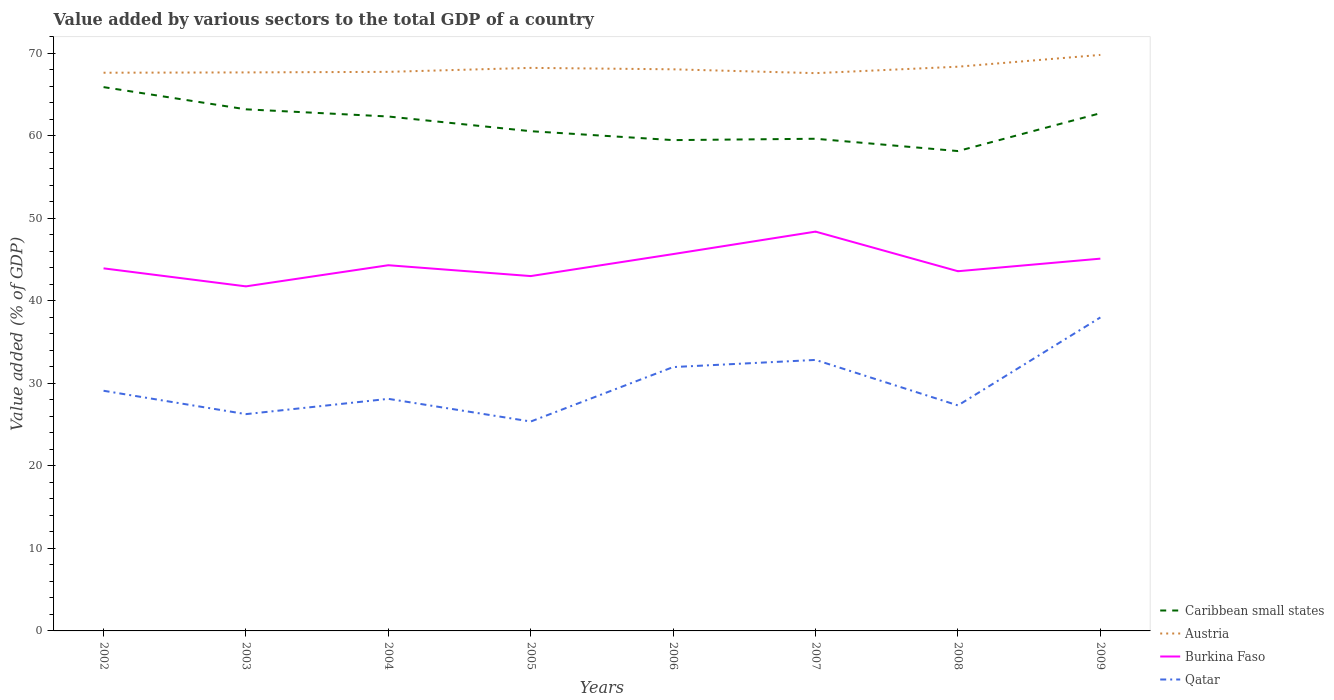How many different coloured lines are there?
Your answer should be compact. 4. Does the line corresponding to Burkina Faso intersect with the line corresponding to Caribbean small states?
Make the answer very short. No. Across all years, what is the maximum value added by various sectors to the total GDP in Caribbean small states?
Make the answer very short. 58.14. What is the total value added by various sectors to the total GDP in Austria in the graph?
Keep it short and to the point. -0.32. What is the difference between the highest and the second highest value added by various sectors to the total GDP in Burkina Faso?
Give a very brief answer. 6.63. What is the difference between the highest and the lowest value added by various sectors to the total GDP in Austria?
Make the answer very short. 3. Is the value added by various sectors to the total GDP in Austria strictly greater than the value added by various sectors to the total GDP in Caribbean small states over the years?
Ensure brevity in your answer.  No. How many lines are there?
Your answer should be very brief. 4. What is the difference between two consecutive major ticks on the Y-axis?
Ensure brevity in your answer.  10. Does the graph contain any zero values?
Make the answer very short. No. Does the graph contain grids?
Your answer should be compact. No. Where does the legend appear in the graph?
Keep it short and to the point. Bottom right. What is the title of the graph?
Keep it short and to the point. Value added by various sectors to the total GDP of a country. What is the label or title of the X-axis?
Offer a terse response. Years. What is the label or title of the Y-axis?
Your answer should be compact. Value added (% of GDP). What is the Value added (% of GDP) in Caribbean small states in 2002?
Give a very brief answer. 65.88. What is the Value added (% of GDP) of Austria in 2002?
Provide a succinct answer. 67.63. What is the Value added (% of GDP) of Burkina Faso in 2002?
Ensure brevity in your answer.  43.93. What is the Value added (% of GDP) of Qatar in 2002?
Make the answer very short. 29.1. What is the Value added (% of GDP) of Caribbean small states in 2003?
Make the answer very short. 63.19. What is the Value added (% of GDP) in Austria in 2003?
Provide a short and direct response. 67.66. What is the Value added (% of GDP) of Burkina Faso in 2003?
Your answer should be compact. 41.74. What is the Value added (% of GDP) of Qatar in 2003?
Make the answer very short. 26.26. What is the Value added (% of GDP) in Caribbean small states in 2004?
Give a very brief answer. 62.32. What is the Value added (% of GDP) of Austria in 2004?
Provide a succinct answer. 67.73. What is the Value added (% of GDP) of Burkina Faso in 2004?
Offer a very short reply. 44.3. What is the Value added (% of GDP) of Qatar in 2004?
Offer a very short reply. 28.12. What is the Value added (% of GDP) in Caribbean small states in 2005?
Keep it short and to the point. 60.54. What is the Value added (% of GDP) in Austria in 2005?
Make the answer very short. 68.21. What is the Value added (% of GDP) in Burkina Faso in 2005?
Give a very brief answer. 42.99. What is the Value added (% of GDP) of Qatar in 2005?
Your answer should be compact. 25.37. What is the Value added (% of GDP) in Caribbean small states in 2006?
Offer a very short reply. 59.46. What is the Value added (% of GDP) in Austria in 2006?
Offer a very short reply. 68.04. What is the Value added (% of GDP) in Burkina Faso in 2006?
Your response must be concise. 45.65. What is the Value added (% of GDP) in Qatar in 2006?
Make the answer very short. 31.97. What is the Value added (% of GDP) of Caribbean small states in 2007?
Offer a terse response. 59.63. What is the Value added (% of GDP) of Austria in 2007?
Your response must be concise. 67.57. What is the Value added (% of GDP) of Burkina Faso in 2007?
Your answer should be compact. 48.38. What is the Value added (% of GDP) of Qatar in 2007?
Provide a succinct answer. 32.83. What is the Value added (% of GDP) in Caribbean small states in 2008?
Keep it short and to the point. 58.14. What is the Value added (% of GDP) of Austria in 2008?
Make the answer very short. 68.36. What is the Value added (% of GDP) in Burkina Faso in 2008?
Provide a short and direct response. 43.58. What is the Value added (% of GDP) in Qatar in 2008?
Make the answer very short. 27.32. What is the Value added (% of GDP) in Caribbean small states in 2009?
Your answer should be very brief. 62.72. What is the Value added (% of GDP) of Austria in 2009?
Your response must be concise. 69.79. What is the Value added (% of GDP) in Burkina Faso in 2009?
Your answer should be compact. 45.1. What is the Value added (% of GDP) in Qatar in 2009?
Provide a short and direct response. 37.98. Across all years, what is the maximum Value added (% of GDP) in Caribbean small states?
Provide a succinct answer. 65.88. Across all years, what is the maximum Value added (% of GDP) in Austria?
Ensure brevity in your answer.  69.79. Across all years, what is the maximum Value added (% of GDP) of Burkina Faso?
Your response must be concise. 48.38. Across all years, what is the maximum Value added (% of GDP) of Qatar?
Provide a succinct answer. 37.98. Across all years, what is the minimum Value added (% of GDP) of Caribbean small states?
Offer a very short reply. 58.14. Across all years, what is the minimum Value added (% of GDP) in Austria?
Your answer should be very brief. 67.57. Across all years, what is the minimum Value added (% of GDP) of Burkina Faso?
Offer a terse response. 41.74. Across all years, what is the minimum Value added (% of GDP) in Qatar?
Your answer should be compact. 25.37. What is the total Value added (% of GDP) in Caribbean small states in the graph?
Offer a very short reply. 491.88. What is the total Value added (% of GDP) in Austria in the graph?
Your answer should be very brief. 544.99. What is the total Value added (% of GDP) in Burkina Faso in the graph?
Offer a terse response. 355.67. What is the total Value added (% of GDP) in Qatar in the graph?
Offer a very short reply. 238.94. What is the difference between the Value added (% of GDP) of Caribbean small states in 2002 and that in 2003?
Provide a short and direct response. 2.69. What is the difference between the Value added (% of GDP) of Austria in 2002 and that in 2003?
Offer a terse response. -0.04. What is the difference between the Value added (% of GDP) of Burkina Faso in 2002 and that in 2003?
Your response must be concise. 2.18. What is the difference between the Value added (% of GDP) of Qatar in 2002 and that in 2003?
Your answer should be compact. 2.83. What is the difference between the Value added (% of GDP) in Caribbean small states in 2002 and that in 2004?
Provide a short and direct response. 3.56. What is the difference between the Value added (% of GDP) in Austria in 2002 and that in 2004?
Offer a very short reply. -0.11. What is the difference between the Value added (% of GDP) in Burkina Faso in 2002 and that in 2004?
Keep it short and to the point. -0.38. What is the difference between the Value added (% of GDP) in Qatar in 2002 and that in 2004?
Make the answer very short. 0.98. What is the difference between the Value added (% of GDP) of Caribbean small states in 2002 and that in 2005?
Provide a short and direct response. 5.34. What is the difference between the Value added (% of GDP) in Austria in 2002 and that in 2005?
Provide a short and direct response. -0.59. What is the difference between the Value added (% of GDP) in Burkina Faso in 2002 and that in 2005?
Your answer should be compact. 0.94. What is the difference between the Value added (% of GDP) in Qatar in 2002 and that in 2005?
Your response must be concise. 3.73. What is the difference between the Value added (% of GDP) of Caribbean small states in 2002 and that in 2006?
Provide a succinct answer. 6.42. What is the difference between the Value added (% of GDP) in Austria in 2002 and that in 2006?
Your answer should be very brief. -0.41. What is the difference between the Value added (% of GDP) of Burkina Faso in 2002 and that in 2006?
Your answer should be compact. -1.73. What is the difference between the Value added (% of GDP) in Qatar in 2002 and that in 2006?
Your answer should be very brief. -2.87. What is the difference between the Value added (% of GDP) in Caribbean small states in 2002 and that in 2007?
Offer a very short reply. 6.25. What is the difference between the Value added (% of GDP) in Austria in 2002 and that in 2007?
Provide a short and direct response. 0.05. What is the difference between the Value added (% of GDP) of Burkina Faso in 2002 and that in 2007?
Give a very brief answer. -4.45. What is the difference between the Value added (% of GDP) of Qatar in 2002 and that in 2007?
Your answer should be compact. -3.74. What is the difference between the Value added (% of GDP) of Caribbean small states in 2002 and that in 2008?
Your answer should be compact. 7.75. What is the difference between the Value added (% of GDP) of Austria in 2002 and that in 2008?
Your response must be concise. -0.73. What is the difference between the Value added (% of GDP) of Burkina Faso in 2002 and that in 2008?
Ensure brevity in your answer.  0.35. What is the difference between the Value added (% of GDP) of Qatar in 2002 and that in 2008?
Give a very brief answer. 1.78. What is the difference between the Value added (% of GDP) in Caribbean small states in 2002 and that in 2009?
Your answer should be compact. 3.16. What is the difference between the Value added (% of GDP) in Austria in 2002 and that in 2009?
Offer a very short reply. -2.16. What is the difference between the Value added (% of GDP) in Burkina Faso in 2002 and that in 2009?
Keep it short and to the point. -1.18. What is the difference between the Value added (% of GDP) in Qatar in 2002 and that in 2009?
Make the answer very short. -8.88. What is the difference between the Value added (% of GDP) of Caribbean small states in 2003 and that in 2004?
Provide a succinct answer. 0.87. What is the difference between the Value added (% of GDP) of Austria in 2003 and that in 2004?
Your answer should be very brief. -0.07. What is the difference between the Value added (% of GDP) of Burkina Faso in 2003 and that in 2004?
Provide a succinct answer. -2.56. What is the difference between the Value added (% of GDP) of Qatar in 2003 and that in 2004?
Provide a succinct answer. -1.85. What is the difference between the Value added (% of GDP) in Caribbean small states in 2003 and that in 2005?
Give a very brief answer. 2.65. What is the difference between the Value added (% of GDP) of Austria in 2003 and that in 2005?
Offer a terse response. -0.55. What is the difference between the Value added (% of GDP) in Burkina Faso in 2003 and that in 2005?
Offer a very short reply. -1.25. What is the difference between the Value added (% of GDP) of Qatar in 2003 and that in 2005?
Your response must be concise. 0.89. What is the difference between the Value added (% of GDP) of Caribbean small states in 2003 and that in 2006?
Provide a short and direct response. 3.73. What is the difference between the Value added (% of GDP) in Austria in 2003 and that in 2006?
Your response must be concise. -0.38. What is the difference between the Value added (% of GDP) of Burkina Faso in 2003 and that in 2006?
Give a very brief answer. -3.91. What is the difference between the Value added (% of GDP) of Qatar in 2003 and that in 2006?
Your answer should be very brief. -5.7. What is the difference between the Value added (% of GDP) in Caribbean small states in 2003 and that in 2007?
Offer a terse response. 3.56. What is the difference between the Value added (% of GDP) of Austria in 2003 and that in 2007?
Provide a succinct answer. 0.09. What is the difference between the Value added (% of GDP) in Burkina Faso in 2003 and that in 2007?
Offer a very short reply. -6.63. What is the difference between the Value added (% of GDP) in Qatar in 2003 and that in 2007?
Your answer should be very brief. -6.57. What is the difference between the Value added (% of GDP) of Caribbean small states in 2003 and that in 2008?
Your answer should be compact. 5.06. What is the difference between the Value added (% of GDP) of Austria in 2003 and that in 2008?
Provide a succinct answer. -0.69. What is the difference between the Value added (% of GDP) in Burkina Faso in 2003 and that in 2008?
Offer a very short reply. -1.83. What is the difference between the Value added (% of GDP) in Qatar in 2003 and that in 2008?
Your answer should be compact. -1.06. What is the difference between the Value added (% of GDP) of Caribbean small states in 2003 and that in 2009?
Offer a very short reply. 0.47. What is the difference between the Value added (% of GDP) of Austria in 2003 and that in 2009?
Provide a short and direct response. -2.12. What is the difference between the Value added (% of GDP) of Burkina Faso in 2003 and that in 2009?
Provide a short and direct response. -3.36. What is the difference between the Value added (% of GDP) of Qatar in 2003 and that in 2009?
Offer a very short reply. -11.71. What is the difference between the Value added (% of GDP) in Caribbean small states in 2004 and that in 2005?
Ensure brevity in your answer.  1.78. What is the difference between the Value added (% of GDP) in Austria in 2004 and that in 2005?
Make the answer very short. -0.48. What is the difference between the Value added (% of GDP) in Burkina Faso in 2004 and that in 2005?
Give a very brief answer. 1.31. What is the difference between the Value added (% of GDP) in Qatar in 2004 and that in 2005?
Your response must be concise. 2.75. What is the difference between the Value added (% of GDP) of Caribbean small states in 2004 and that in 2006?
Ensure brevity in your answer.  2.86. What is the difference between the Value added (% of GDP) in Austria in 2004 and that in 2006?
Your response must be concise. -0.31. What is the difference between the Value added (% of GDP) in Burkina Faso in 2004 and that in 2006?
Provide a short and direct response. -1.35. What is the difference between the Value added (% of GDP) in Qatar in 2004 and that in 2006?
Offer a very short reply. -3.85. What is the difference between the Value added (% of GDP) in Caribbean small states in 2004 and that in 2007?
Your answer should be very brief. 2.69. What is the difference between the Value added (% of GDP) in Austria in 2004 and that in 2007?
Provide a succinct answer. 0.16. What is the difference between the Value added (% of GDP) of Burkina Faso in 2004 and that in 2007?
Keep it short and to the point. -4.07. What is the difference between the Value added (% of GDP) in Qatar in 2004 and that in 2007?
Offer a terse response. -4.72. What is the difference between the Value added (% of GDP) of Caribbean small states in 2004 and that in 2008?
Your response must be concise. 4.19. What is the difference between the Value added (% of GDP) of Austria in 2004 and that in 2008?
Your answer should be compact. -0.62. What is the difference between the Value added (% of GDP) of Burkina Faso in 2004 and that in 2008?
Your answer should be very brief. 0.73. What is the difference between the Value added (% of GDP) of Qatar in 2004 and that in 2008?
Offer a terse response. 0.8. What is the difference between the Value added (% of GDP) of Caribbean small states in 2004 and that in 2009?
Provide a short and direct response. -0.4. What is the difference between the Value added (% of GDP) of Austria in 2004 and that in 2009?
Your response must be concise. -2.05. What is the difference between the Value added (% of GDP) in Burkina Faso in 2004 and that in 2009?
Provide a succinct answer. -0.8. What is the difference between the Value added (% of GDP) in Qatar in 2004 and that in 2009?
Offer a terse response. -9.86. What is the difference between the Value added (% of GDP) of Caribbean small states in 2005 and that in 2006?
Your answer should be compact. 1.08. What is the difference between the Value added (% of GDP) in Austria in 2005 and that in 2006?
Offer a very short reply. 0.17. What is the difference between the Value added (% of GDP) in Burkina Faso in 2005 and that in 2006?
Your answer should be compact. -2.66. What is the difference between the Value added (% of GDP) of Qatar in 2005 and that in 2006?
Your answer should be compact. -6.6. What is the difference between the Value added (% of GDP) in Caribbean small states in 2005 and that in 2007?
Make the answer very short. 0.91. What is the difference between the Value added (% of GDP) of Austria in 2005 and that in 2007?
Your response must be concise. 0.64. What is the difference between the Value added (% of GDP) of Burkina Faso in 2005 and that in 2007?
Your answer should be compact. -5.39. What is the difference between the Value added (% of GDP) of Qatar in 2005 and that in 2007?
Give a very brief answer. -7.46. What is the difference between the Value added (% of GDP) in Caribbean small states in 2005 and that in 2008?
Keep it short and to the point. 2.41. What is the difference between the Value added (% of GDP) of Austria in 2005 and that in 2008?
Keep it short and to the point. -0.14. What is the difference between the Value added (% of GDP) in Burkina Faso in 2005 and that in 2008?
Offer a very short reply. -0.59. What is the difference between the Value added (% of GDP) in Qatar in 2005 and that in 2008?
Your response must be concise. -1.95. What is the difference between the Value added (% of GDP) in Caribbean small states in 2005 and that in 2009?
Ensure brevity in your answer.  -2.18. What is the difference between the Value added (% of GDP) of Austria in 2005 and that in 2009?
Keep it short and to the point. -1.57. What is the difference between the Value added (% of GDP) in Burkina Faso in 2005 and that in 2009?
Give a very brief answer. -2.11. What is the difference between the Value added (% of GDP) of Qatar in 2005 and that in 2009?
Make the answer very short. -12.61. What is the difference between the Value added (% of GDP) in Caribbean small states in 2006 and that in 2007?
Make the answer very short. -0.16. What is the difference between the Value added (% of GDP) of Austria in 2006 and that in 2007?
Ensure brevity in your answer.  0.47. What is the difference between the Value added (% of GDP) of Burkina Faso in 2006 and that in 2007?
Offer a very short reply. -2.72. What is the difference between the Value added (% of GDP) of Qatar in 2006 and that in 2007?
Give a very brief answer. -0.87. What is the difference between the Value added (% of GDP) in Caribbean small states in 2006 and that in 2008?
Your response must be concise. 1.33. What is the difference between the Value added (% of GDP) of Austria in 2006 and that in 2008?
Offer a terse response. -0.32. What is the difference between the Value added (% of GDP) of Burkina Faso in 2006 and that in 2008?
Ensure brevity in your answer.  2.08. What is the difference between the Value added (% of GDP) in Qatar in 2006 and that in 2008?
Offer a terse response. 4.65. What is the difference between the Value added (% of GDP) of Caribbean small states in 2006 and that in 2009?
Provide a short and direct response. -3.26. What is the difference between the Value added (% of GDP) of Austria in 2006 and that in 2009?
Provide a short and direct response. -1.75. What is the difference between the Value added (% of GDP) of Burkina Faso in 2006 and that in 2009?
Offer a very short reply. 0.55. What is the difference between the Value added (% of GDP) of Qatar in 2006 and that in 2009?
Keep it short and to the point. -6.01. What is the difference between the Value added (% of GDP) of Caribbean small states in 2007 and that in 2008?
Your answer should be compact. 1.49. What is the difference between the Value added (% of GDP) in Austria in 2007 and that in 2008?
Your answer should be compact. -0.78. What is the difference between the Value added (% of GDP) in Burkina Faso in 2007 and that in 2008?
Offer a very short reply. 4.8. What is the difference between the Value added (% of GDP) in Qatar in 2007 and that in 2008?
Offer a terse response. 5.51. What is the difference between the Value added (% of GDP) in Caribbean small states in 2007 and that in 2009?
Keep it short and to the point. -3.09. What is the difference between the Value added (% of GDP) of Austria in 2007 and that in 2009?
Your response must be concise. -2.21. What is the difference between the Value added (% of GDP) in Burkina Faso in 2007 and that in 2009?
Your response must be concise. 3.27. What is the difference between the Value added (% of GDP) in Qatar in 2007 and that in 2009?
Make the answer very short. -5.14. What is the difference between the Value added (% of GDP) of Caribbean small states in 2008 and that in 2009?
Provide a short and direct response. -4.58. What is the difference between the Value added (% of GDP) of Austria in 2008 and that in 2009?
Keep it short and to the point. -1.43. What is the difference between the Value added (% of GDP) in Burkina Faso in 2008 and that in 2009?
Your answer should be compact. -1.52. What is the difference between the Value added (% of GDP) of Qatar in 2008 and that in 2009?
Make the answer very short. -10.66. What is the difference between the Value added (% of GDP) of Caribbean small states in 2002 and the Value added (% of GDP) of Austria in 2003?
Your answer should be compact. -1.78. What is the difference between the Value added (% of GDP) in Caribbean small states in 2002 and the Value added (% of GDP) in Burkina Faso in 2003?
Provide a short and direct response. 24.14. What is the difference between the Value added (% of GDP) in Caribbean small states in 2002 and the Value added (% of GDP) in Qatar in 2003?
Offer a terse response. 39.62. What is the difference between the Value added (% of GDP) in Austria in 2002 and the Value added (% of GDP) in Burkina Faso in 2003?
Provide a short and direct response. 25.88. What is the difference between the Value added (% of GDP) of Austria in 2002 and the Value added (% of GDP) of Qatar in 2003?
Give a very brief answer. 41.36. What is the difference between the Value added (% of GDP) in Burkina Faso in 2002 and the Value added (% of GDP) in Qatar in 2003?
Your response must be concise. 17.66. What is the difference between the Value added (% of GDP) of Caribbean small states in 2002 and the Value added (% of GDP) of Austria in 2004?
Your answer should be compact. -1.85. What is the difference between the Value added (% of GDP) in Caribbean small states in 2002 and the Value added (% of GDP) in Burkina Faso in 2004?
Give a very brief answer. 21.58. What is the difference between the Value added (% of GDP) of Caribbean small states in 2002 and the Value added (% of GDP) of Qatar in 2004?
Offer a terse response. 37.77. What is the difference between the Value added (% of GDP) of Austria in 2002 and the Value added (% of GDP) of Burkina Faso in 2004?
Offer a very short reply. 23.32. What is the difference between the Value added (% of GDP) of Austria in 2002 and the Value added (% of GDP) of Qatar in 2004?
Your answer should be very brief. 39.51. What is the difference between the Value added (% of GDP) in Burkina Faso in 2002 and the Value added (% of GDP) in Qatar in 2004?
Make the answer very short. 15.81. What is the difference between the Value added (% of GDP) of Caribbean small states in 2002 and the Value added (% of GDP) of Austria in 2005?
Offer a very short reply. -2.33. What is the difference between the Value added (% of GDP) of Caribbean small states in 2002 and the Value added (% of GDP) of Burkina Faso in 2005?
Your response must be concise. 22.89. What is the difference between the Value added (% of GDP) in Caribbean small states in 2002 and the Value added (% of GDP) in Qatar in 2005?
Offer a very short reply. 40.51. What is the difference between the Value added (% of GDP) in Austria in 2002 and the Value added (% of GDP) in Burkina Faso in 2005?
Your answer should be compact. 24.64. What is the difference between the Value added (% of GDP) in Austria in 2002 and the Value added (% of GDP) in Qatar in 2005?
Keep it short and to the point. 42.26. What is the difference between the Value added (% of GDP) of Burkina Faso in 2002 and the Value added (% of GDP) of Qatar in 2005?
Provide a short and direct response. 18.56. What is the difference between the Value added (% of GDP) in Caribbean small states in 2002 and the Value added (% of GDP) in Austria in 2006?
Your answer should be very brief. -2.16. What is the difference between the Value added (% of GDP) of Caribbean small states in 2002 and the Value added (% of GDP) of Burkina Faso in 2006?
Make the answer very short. 20.23. What is the difference between the Value added (% of GDP) of Caribbean small states in 2002 and the Value added (% of GDP) of Qatar in 2006?
Give a very brief answer. 33.92. What is the difference between the Value added (% of GDP) in Austria in 2002 and the Value added (% of GDP) in Burkina Faso in 2006?
Make the answer very short. 21.97. What is the difference between the Value added (% of GDP) in Austria in 2002 and the Value added (% of GDP) in Qatar in 2006?
Ensure brevity in your answer.  35.66. What is the difference between the Value added (% of GDP) of Burkina Faso in 2002 and the Value added (% of GDP) of Qatar in 2006?
Your answer should be compact. 11.96. What is the difference between the Value added (% of GDP) of Caribbean small states in 2002 and the Value added (% of GDP) of Austria in 2007?
Give a very brief answer. -1.69. What is the difference between the Value added (% of GDP) of Caribbean small states in 2002 and the Value added (% of GDP) of Burkina Faso in 2007?
Your response must be concise. 17.51. What is the difference between the Value added (% of GDP) in Caribbean small states in 2002 and the Value added (% of GDP) in Qatar in 2007?
Offer a terse response. 33.05. What is the difference between the Value added (% of GDP) in Austria in 2002 and the Value added (% of GDP) in Burkina Faso in 2007?
Provide a succinct answer. 19.25. What is the difference between the Value added (% of GDP) in Austria in 2002 and the Value added (% of GDP) in Qatar in 2007?
Your answer should be very brief. 34.79. What is the difference between the Value added (% of GDP) of Burkina Faso in 2002 and the Value added (% of GDP) of Qatar in 2007?
Make the answer very short. 11.09. What is the difference between the Value added (% of GDP) of Caribbean small states in 2002 and the Value added (% of GDP) of Austria in 2008?
Offer a very short reply. -2.47. What is the difference between the Value added (% of GDP) of Caribbean small states in 2002 and the Value added (% of GDP) of Burkina Faso in 2008?
Offer a terse response. 22.3. What is the difference between the Value added (% of GDP) of Caribbean small states in 2002 and the Value added (% of GDP) of Qatar in 2008?
Offer a very short reply. 38.56. What is the difference between the Value added (% of GDP) in Austria in 2002 and the Value added (% of GDP) in Burkina Faso in 2008?
Offer a very short reply. 24.05. What is the difference between the Value added (% of GDP) of Austria in 2002 and the Value added (% of GDP) of Qatar in 2008?
Provide a short and direct response. 40.31. What is the difference between the Value added (% of GDP) in Burkina Faso in 2002 and the Value added (% of GDP) in Qatar in 2008?
Keep it short and to the point. 16.6. What is the difference between the Value added (% of GDP) of Caribbean small states in 2002 and the Value added (% of GDP) of Austria in 2009?
Provide a succinct answer. -3.9. What is the difference between the Value added (% of GDP) of Caribbean small states in 2002 and the Value added (% of GDP) of Burkina Faso in 2009?
Give a very brief answer. 20.78. What is the difference between the Value added (% of GDP) of Caribbean small states in 2002 and the Value added (% of GDP) of Qatar in 2009?
Offer a very short reply. 27.9. What is the difference between the Value added (% of GDP) of Austria in 2002 and the Value added (% of GDP) of Burkina Faso in 2009?
Your answer should be very brief. 22.52. What is the difference between the Value added (% of GDP) of Austria in 2002 and the Value added (% of GDP) of Qatar in 2009?
Your answer should be compact. 29.65. What is the difference between the Value added (% of GDP) in Burkina Faso in 2002 and the Value added (% of GDP) in Qatar in 2009?
Provide a succinct answer. 5.95. What is the difference between the Value added (% of GDP) of Caribbean small states in 2003 and the Value added (% of GDP) of Austria in 2004?
Offer a terse response. -4.54. What is the difference between the Value added (% of GDP) of Caribbean small states in 2003 and the Value added (% of GDP) of Burkina Faso in 2004?
Make the answer very short. 18.89. What is the difference between the Value added (% of GDP) in Caribbean small states in 2003 and the Value added (% of GDP) in Qatar in 2004?
Your response must be concise. 35.08. What is the difference between the Value added (% of GDP) of Austria in 2003 and the Value added (% of GDP) of Burkina Faso in 2004?
Provide a succinct answer. 23.36. What is the difference between the Value added (% of GDP) in Austria in 2003 and the Value added (% of GDP) in Qatar in 2004?
Your answer should be compact. 39.55. What is the difference between the Value added (% of GDP) in Burkina Faso in 2003 and the Value added (% of GDP) in Qatar in 2004?
Your answer should be compact. 13.63. What is the difference between the Value added (% of GDP) in Caribbean small states in 2003 and the Value added (% of GDP) in Austria in 2005?
Provide a short and direct response. -5.02. What is the difference between the Value added (% of GDP) of Caribbean small states in 2003 and the Value added (% of GDP) of Burkina Faso in 2005?
Your answer should be very brief. 20.2. What is the difference between the Value added (% of GDP) in Caribbean small states in 2003 and the Value added (% of GDP) in Qatar in 2005?
Provide a succinct answer. 37.82. What is the difference between the Value added (% of GDP) in Austria in 2003 and the Value added (% of GDP) in Burkina Faso in 2005?
Make the answer very short. 24.67. What is the difference between the Value added (% of GDP) of Austria in 2003 and the Value added (% of GDP) of Qatar in 2005?
Offer a terse response. 42.29. What is the difference between the Value added (% of GDP) of Burkina Faso in 2003 and the Value added (% of GDP) of Qatar in 2005?
Your answer should be compact. 16.37. What is the difference between the Value added (% of GDP) of Caribbean small states in 2003 and the Value added (% of GDP) of Austria in 2006?
Provide a short and direct response. -4.85. What is the difference between the Value added (% of GDP) in Caribbean small states in 2003 and the Value added (% of GDP) in Burkina Faso in 2006?
Keep it short and to the point. 17.54. What is the difference between the Value added (% of GDP) of Caribbean small states in 2003 and the Value added (% of GDP) of Qatar in 2006?
Your response must be concise. 31.23. What is the difference between the Value added (% of GDP) of Austria in 2003 and the Value added (% of GDP) of Burkina Faso in 2006?
Offer a terse response. 22.01. What is the difference between the Value added (% of GDP) in Austria in 2003 and the Value added (% of GDP) in Qatar in 2006?
Make the answer very short. 35.7. What is the difference between the Value added (% of GDP) in Burkina Faso in 2003 and the Value added (% of GDP) in Qatar in 2006?
Keep it short and to the point. 9.78. What is the difference between the Value added (% of GDP) of Caribbean small states in 2003 and the Value added (% of GDP) of Austria in 2007?
Offer a terse response. -4.38. What is the difference between the Value added (% of GDP) in Caribbean small states in 2003 and the Value added (% of GDP) in Burkina Faso in 2007?
Make the answer very short. 14.82. What is the difference between the Value added (% of GDP) in Caribbean small states in 2003 and the Value added (% of GDP) in Qatar in 2007?
Make the answer very short. 30.36. What is the difference between the Value added (% of GDP) of Austria in 2003 and the Value added (% of GDP) of Burkina Faso in 2007?
Your answer should be very brief. 19.29. What is the difference between the Value added (% of GDP) in Austria in 2003 and the Value added (% of GDP) in Qatar in 2007?
Make the answer very short. 34.83. What is the difference between the Value added (% of GDP) in Burkina Faso in 2003 and the Value added (% of GDP) in Qatar in 2007?
Ensure brevity in your answer.  8.91. What is the difference between the Value added (% of GDP) of Caribbean small states in 2003 and the Value added (% of GDP) of Austria in 2008?
Your answer should be compact. -5.16. What is the difference between the Value added (% of GDP) of Caribbean small states in 2003 and the Value added (% of GDP) of Burkina Faso in 2008?
Your answer should be very brief. 19.61. What is the difference between the Value added (% of GDP) of Caribbean small states in 2003 and the Value added (% of GDP) of Qatar in 2008?
Provide a short and direct response. 35.87. What is the difference between the Value added (% of GDP) in Austria in 2003 and the Value added (% of GDP) in Burkina Faso in 2008?
Your answer should be compact. 24.09. What is the difference between the Value added (% of GDP) of Austria in 2003 and the Value added (% of GDP) of Qatar in 2008?
Keep it short and to the point. 40.34. What is the difference between the Value added (% of GDP) of Burkina Faso in 2003 and the Value added (% of GDP) of Qatar in 2008?
Ensure brevity in your answer.  14.42. What is the difference between the Value added (% of GDP) of Caribbean small states in 2003 and the Value added (% of GDP) of Austria in 2009?
Your response must be concise. -6.59. What is the difference between the Value added (% of GDP) of Caribbean small states in 2003 and the Value added (% of GDP) of Burkina Faso in 2009?
Offer a very short reply. 18.09. What is the difference between the Value added (% of GDP) of Caribbean small states in 2003 and the Value added (% of GDP) of Qatar in 2009?
Provide a short and direct response. 25.21. What is the difference between the Value added (% of GDP) of Austria in 2003 and the Value added (% of GDP) of Burkina Faso in 2009?
Make the answer very short. 22.56. What is the difference between the Value added (% of GDP) of Austria in 2003 and the Value added (% of GDP) of Qatar in 2009?
Your answer should be compact. 29.69. What is the difference between the Value added (% of GDP) of Burkina Faso in 2003 and the Value added (% of GDP) of Qatar in 2009?
Provide a short and direct response. 3.77. What is the difference between the Value added (% of GDP) in Caribbean small states in 2004 and the Value added (% of GDP) in Austria in 2005?
Offer a terse response. -5.89. What is the difference between the Value added (% of GDP) of Caribbean small states in 2004 and the Value added (% of GDP) of Burkina Faso in 2005?
Your answer should be very brief. 19.33. What is the difference between the Value added (% of GDP) in Caribbean small states in 2004 and the Value added (% of GDP) in Qatar in 2005?
Ensure brevity in your answer.  36.95. What is the difference between the Value added (% of GDP) of Austria in 2004 and the Value added (% of GDP) of Burkina Faso in 2005?
Your answer should be very brief. 24.74. What is the difference between the Value added (% of GDP) of Austria in 2004 and the Value added (% of GDP) of Qatar in 2005?
Your answer should be compact. 42.36. What is the difference between the Value added (% of GDP) in Burkina Faso in 2004 and the Value added (% of GDP) in Qatar in 2005?
Make the answer very short. 18.93. What is the difference between the Value added (% of GDP) in Caribbean small states in 2004 and the Value added (% of GDP) in Austria in 2006?
Offer a terse response. -5.72. What is the difference between the Value added (% of GDP) of Caribbean small states in 2004 and the Value added (% of GDP) of Burkina Faso in 2006?
Your answer should be very brief. 16.67. What is the difference between the Value added (% of GDP) of Caribbean small states in 2004 and the Value added (% of GDP) of Qatar in 2006?
Offer a terse response. 30.36. What is the difference between the Value added (% of GDP) of Austria in 2004 and the Value added (% of GDP) of Burkina Faso in 2006?
Your answer should be very brief. 22.08. What is the difference between the Value added (% of GDP) of Austria in 2004 and the Value added (% of GDP) of Qatar in 2006?
Your response must be concise. 35.77. What is the difference between the Value added (% of GDP) of Burkina Faso in 2004 and the Value added (% of GDP) of Qatar in 2006?
Provide a short and direct response. 12.34. What is the difference between the Value added (% of GDP) of Caribbean small states in 2004 and the Value added (% of GDP) of Austria in 2007?
Offer a very short reply. -5.25. What is the difference between the Value added (% of GDP) in Caribbean small states in 2004 and the Value added (% of GDP) in Burkina Faso in 2007?
Offer a very short reply. 13.95. What is the difference between the Value added (% of GDP) of Caribbean small states in 2004 and the Value added (% of GDP) of Qatar in 2007?
Provide a succinct answer. 29.49. What is the difference between the Value added (% of GDP) of Austria in 2004 and the Value added (% of GDP) of Burkina Faso in 2007?
Your answer should be very brief. 19.36. What is the difference between the Value added (% of GDP) in Austria in 2004 and the Value added (% of GDP) in Qatar in 2007?
Offer a terse response. 34.9. What is the difference between the Value added (% of GDP) in Burkina Faso in 2004 and the Value added (% of GDP) in Qatar in 2007?
Ensure brevity in your answer.  11.47. What is the difference between the Value added (% of GDP) in Caribbean small states in 2004 and the Value added (% of GDP) in Austria in 2008?
Your answer should be very brief. -6.03. What is the difference between the Value added (% of GDP) of Caribbean small states in 2004 and the Value added (% of GDP) of Burkina Faso in 2008?
Give a very brief answer. 18.74. What is the difference between the Value added (% of GDP) of Caribbean small states in 2004 and the Value added (% of GDP) of Qatar in 2008?
Offer a terse response. 35. What is the difference between the Value added (% of GDP) in Austria in 2004 and the Value added (% of GDP) in Burkina Faso in 2008?
Offer a very short reply. 24.15. What is the difference between the Value added (% of GDP) of Austria in 2004 and the Value added (% of GDP) of Qatar in 2008?
Your response must be concise. 40.41. What is the difference between the Value added (% of GDP) in Burkina Faso in 2004 and the Value added (% of GDP) in Qatar in 2008?
Provide a succinct answer. 16.98. What is the difference between the Value added (% of GDP) in Caribbean small states in 2004 and the Value added (% of GDP) in Austria in 2009?
Make the answer very short. -7.46. What is the difference between the Value added (% of GDP) of Caribbean small states in 2004 and the Value added (% of GDP) of Burkina Faso in 2009?
Keep it short and to the point. 17.22. What is the difference between the Value added (% of GDP) in Caribbean small states in 2004 and the Value added (% of GDP) in Qatar in 2009?
Your response must be concise. 24.34. What is the difference between the Value added (% of GDP) in Austria in 2004 and the Value added (% of GDP) in Burkina Faso in 2009?
Provide a succinct answer. 22.63. What is the difference between the Value added (% of GDP) of Austria in 2004 and the Value added (% of GDP) of Qatar in 2009?
Your response must be concise. 29.76. What is the difference between the Value added (% of GDP) in Burkina Faso in 2004 and the Value added (% of GDP) in Qatar in 2009?
Ensure brevity in your answer.  6.33. What is the difference between the Value added (% of GDP) of Caribbean small states in 2005 and the Value added (% of GDP) of Austria in 2006?
Your answer should be compact. -7.5. What is the difference between the Value added (% of GDP) of Caribbean small states in 2005 and the Value added (% of GDP) of Burkina Faso in 2006?
Make the answer very short. 14.89. What is the difference between the Value added (% of GDP) of Caribbean small states in 2005 and the Value added (% of GDP) of Qatar in 2006?
Keep it short and to the point. 28.58. What is the difference between the Value added (% of GDP) of Austria in 2005 and the Value added (% of GDP) of Burkina Faso in 2006?
Ensure brevity in your answer.  22.56. What is the difference between the Value added (% of GDP) of Austria in 2005 and the Value added (% of GDP) of Qatar in 2006?
Your answer should be very brief. 36.25. What is the difference between the Value added (% of GDP) of Burkina Faso in 2005 and the Value added (% of GDP) of Qatar in 2006?
Your answer should be very brief. 11.02. What is the difference between the Value added (% of GDP) of Caribbean small states in 2005 and the Value added (% of GDP) of Austria in 2007?
Make the answer very short. -7.03. What is the difference between the Value added (% of GDP) of Caribbean small states in 2005 and the Value added (% of GDP) of Burkina Faso in 2007?
Offer a terse response. 12.17. What is the difference between the Value added (% of GDP) in Caribbean small states in 2005 and the Value added (% of GDP) in Qatar in 2007?
Offer a terse response. 27.71. What is the difference between the Value added (% of GDP) of Austria in 2005 and the Value added (% of GDP) of Burkina Faso in 2007?
Make the answer very short. 19.84. What is the difference between the Value added (% of GDP) in Austria in 2005 and the Value added (% of GDP) in Qatar in 2007?
Offer a terse response. 35.38. What is the difference between the Value added (% of GDP) of Burkina Faso in 2005 and the Value added (% of GDP) of Qatar in 2007?
Offer a very short reply. 10.16. What is the difference between the Value added (% of GDP) in Caribbean small states in 2005 and the Value added (% of GDP) in Austria in 2008?
Provide a short and direct response. -7.81. What is the difference between the Value added (% of GDP) of Caribbean small states in 2005 and the Value added (% of GDP) of Burkina Faso in 2008?
Provide a short and direct response. 16.96. What is the difference between the Value added (% of GDP) in Caribbean small states in 2005 and the Value added (% of GDP) in Qatar in 2008?
Your response must be concise. 33.22. What is the difference between the Value added (% of GDP) of Austria in 2005 and the Value added (% of GDP) of Burkina Faso in 2008?
Your response must be concise. 24.64. What is the difference between the Value added (% of GDP) in Austria in 2005 and the Value added (% of GDP) in Qatar in 2008?
Provide a succinct answer. 40.89. What is the difference between the Value added (% of GDP) of Burkina Faso in 2005 and the Value added (% of GDP) of Qatar in 2008?
Your answer should be very brief. 15.67. What is the difference between the Value added (% of GDP) of Caribbean small states in 2005 and the Value added (% of GDP) of Austria in 2009?
Ensure brevity in your answer.  -9.24. What is the difference between the Value added (% of GDP) of Caribbean small states in 2005 and the Value added (% of GDP) of Burkina Faso in 2009?
Offer a terse response. 15.44. What is the difference between the Value added (% of GDP) in Caribbean small states in 2005 and the Value added (% of GDP) in Qatar in 2009?
Provide a short and direct response. 22.56. What is the difference between the Value added (% of GDP) in Austria in 2005 and the Value added (% of GDP) in Burkina Faso in 2009?
Keep it short and to the point. 23.11. What is the difference between the Value added (% of GDP) of Austria in 2005 and the Value added (% of GDP) of Qatar in 2009?
Your answer should be compact. 30.24. What is the difference between the Value added (% of GDP) in Burkina Faso in 2005 and the Value added (% of GDP) in Qatar in 2009?
Give a very brief answer. 5.01. What is the difference between the Value added (% of GDP) of Caribbean small states in 2006 and the Value added (% of GDP) of Austria in 2007?
Give a very brief answer. -8.11. What is the difference between the Value added (% of GDP) of Caribbean small states in 2006 and the Value added (% of GDP) of Burkina Faso in 2007?
Ensure brevity in your answer.  11.09. What is the difference between the Value added (% of GDP) in Caribbean small states in 2006 and the Value added (% of GDP) in Qatar in 2007?
Ensure brevity in your answer.  26.63. What is the difference between the Value added (% of GDP) of Austria in 2006 and the Value added (% of GDP) of Burkina Faso in 2007?
Ensure brevity in your answer.  19.66. What is the difference between the Value added (% of GDP) of Austria in 2006 and the Value added (% of GDP) of Qatar in 2007?
Give a very brief answer. 35.21. What is the difference between the Value added (% of GDP) in Burkina Faso in 2006 and the Value added (% of GDP) in Qatar in 2007?
Your answer should be compact. 12.82. What is the difference between the Value added (% of GDP) of Caribbean small states in 2006 and the Value added (% of GDP) of Austria in 2008?
Make the answer very short. -8.89. What is the difference between the Value added (% of GDP) in Caribbean small states in 2006 and the Value added (% of GDP) in Burkina Faso in 2008?
Your answer should be very brief. 15.88. What is the difference between the Value added (% of GDP) of Caribbean small states in 2006 and the Value added (% of GDP) of Qatar in 2008?
Your answer should be very brief. 32.14. What is the difference between the Value added (% of GDP) in Austria in 2006 and the Value added (% of GDP) in Burkina Faso in 2008?
Keep it short and to the point. 24.46. What is the difference between the Value added (% of GDP) of Austria in 2006 and the Value added (% of GDP) of Qatar in 2008?
Make the answer very short. 40.72. What is the difference between the Value added (% of GDP) of Burkina Faso in 2006 and the Value added (% of GDP) of Qatar in 2008?
Your response must be concise. 18.33. What is the difference between the Value added (% of GDP) of Caribbean small states in 2006 and the Value added (% of GDP) of Austria in 2009?
Your answer should be very brief. -10.32. What is the difference between the Value added (% of GDP) in Caribbean small states in 2006 and the Value added (% of GDP) in Burkina Faso in 2009?
Provide a short and direct response. 14.36. What is the difference between the Value added (% of GDP) of Caribbean small states in 2006 and the Value added (% of GDP) of Qatar in 2009?
Provide a short and direct response. 21.49. What is the difference between the Value added (% of GDP) of Austria in 2006 and the Value added (% of GDP) of Burkina Faso in 2009?
Provide a short and direct response. 22.94. What is the difference between the Value added (% of GDP) in Austria in 2006 and the Value added (% of GDP) in Qatar in 2009?
Your answer should be compact. 30.06. What is the difference between the Value added (% of GDP) in Burkina Faso in 2006 and the Value added (% of GDP) in Qatar in 2009?
Keep it short and to the point. 7.68. What is the difference between the Value added (% of GDP) in Caribbean small states in 2007 and the Value added (% of GDP) in Austria in 2008?
Your response must be concise. -8.73. What is the difference between the Value added (% of GDP) of Caribbean small states in 2007 and the Value added (% of GDP) of Burkina Faso in 2008?
Give a very brief answer. 16.05. What is the difference between the Value added (% of GDP) in Caribbean small states in 2007 and the Value added (% of GDP) in Qatar in 2008?
Your answer should be compact. 32.31. What is the difference between the Value added (% of GDP) of Austria in 2007 and the Value added (% of GDP) of Burkina Faso in 2008?
Give a very brief answer. 24. What is the difference between the Value added (% of GDP) in Austria in 2007 and the Value added (% of GDP) in Qatar in 2008?
Keep it short and to the point. 40.25. What is the difference between the Value added (% of GDP) in Burkina Faso in 2007 and the Value added (% of GDP) in Qatar in 2008?
Provide a short and direct response. 21.06. What is the difference between the Value added (% of GDP) of Caribbean small states in 2007 and the Value added (% of GDP) of Austria in 2009?
Provide a succinct answer. -10.16. What is the difference between the Value added (% of GDP) in Caribbean small states in 2007 and the Value added (% of GDP) in Burkina Faso in 2009?
Your answer should be very brief. 14.53. What is the difference between the Value added (% of GDP) of Caribbean small states in 2007 and the Value added (% of GDP) of Qatar in 2009?
Your answer should be very brief. 21.65. What is the difference between the Value added (% of GDP) in Austria in 2007 and the Value added (% of GDP) in Burkina Faso in 2009?
Offer a terse response. 22.47. What is the difference between the Value added (% of GDP) of Austria in 2007 and the Value added (% of GDP) of Qatar in 2009?
Keep it short and to the point. 29.6. What is the difference between the Value added (% of GDP) of Burkina Faso in 2007 and the Value added (% of GDP) of Qatar in 2009?
Your answer should be very brief. 10.4. What is the difference between the Value added (% of GDP) of Caribbean small states in 2008 and the Value added (% of GDP) of Austria in 2009?
Your answer should be compact. -11.65. What is the difference between the Value added (% of GDP) of Caribbean small states in 2008 and the Value added (% of GDP) of Burkina Faso in 2009?
Give a very brief answer. 13.03. What is the difference between the Value added (% of GDP) of Caribbean small states in 2008 and the Value added (% of GDP) of Qatar in 2009?
Your answer should be compact. 20.16. What is the difference between the Value added (% of GDP) in Austria in 2008 and the Value added (% of GDP) in Burkina Faso in 2009?
Provide a short and direct response. 23.25. What is the difference between the Value added (% of GDP) in Austria in 2008 and the Value added (% of GDP) in Qatar in 2009?
Ensure brevity in your answer.  30.38. What is the difference between the Value added (% of GDP) in Burkina Faso in 2008 and the Value added (% of GDP) in Qatar in 2009?
Provide a short and direct response. 5.6. What is the average Value added (% of GDP) of Caribbean small states per year?
Offer a very short reply. 61.49. What is the average Value added (% of GDP) of Austria per year?
Keep it short and to the point. 68.12. What is the average Value added (% of GDP) of Burkina Faso per year?
Offer a very short reply. 44.46. What is the average Value added (% of GDP) in Qatar per year?
Offer a terse response. 29.87. In the year 2002, what is the difference between the Value added (% of GDP) of Caribbean small states and Value added (% of GDP) of Austria?
Keep it short and to the point. -1.74. In the year 2002, what is the difference between the Value added (% of GDP) in Caribbean small states and Value added (% of GDP) in Burkina Faso?
Your answer should be compact. 21.96. In the year 2002, what is the difference between the Value added (% of GDP) of Caribbean small states and Value added (% of GDP) of Qatar?
Keep it short and to the point. 36.79. In the year 2002, what is the difference between the Value added (% of GDP) of Austria and Value added (% of GDP) of Burkina Faso?
Your response must be concise. 23.7. In the year 2002, what is the difference between the Value added (% of GDP) in Austria and Value added (% of GDP) in Qatar?
Your answer should be compact. 38.53. In the year 2002, what is the difference between the Value added (% of GDP) in Burkina Faso and Value added (% of GDP) in Qatar?
Give a very brief answer. 14.83. In the year 2003, what is the difference between the Value added (% of GDP) in Caribbean small states and Value added (% of GDP) in Austria?
Your answer should be compact. -4.47. In the year 2003, what is the difference between the Value added (% of GDP) of Caribbean small states and Value added (% of GDP) of Burkina Faso?
Make the answer very short. 21.45. In the year 2003, what is the difference between the Value added (% of GDP) of Caribbean small states and Value added (% of GDP) of Qatar?
Make the answer very short. 36.93. In the year 2003, what is the difference between the Value added (% of GDP) of Austria and Value added (% of GDP) of Burkina Faso?
Provide a short and direct response. 25.92. In the year 2003, what is the difference between the Value added (% of GDP) of Austria and Value added (% of GDP) of Qatar?
Your answer should be compact. 41.4. In the year 2003, what is the difference between the Value added (% of GDP) in Burkina Faso and Value added (% of GDP) in Qatar?
Your response must be concise. 15.48. In the year 2004, what is the difference between the Value added (% of GDP) of Caribbean small states and Value added (% of GDP) of Austria?
Offer a terse response. -5.41. In the year 2004, what is the difference between the Value added (% of GDP) of Caribbean small states and Value added (% of GDP) of Burkina Faso?
Ensure brevity in your answer.  18.02. In the year 2004, what is the difference between the Value added (% of GDP) of Caribbean small states and Value added (% of GDP) of Qatar?
Ensure brevity in your answer.  34.21. In the year 2004, what is the difference between the Value added (% of GDP) of Austria and Value added (% of GDP) of Burkina Faso?
Offer a very short reply. 23.43. In the year 2004, what is the difference between the Value added (% of GDP) of Austria and Value added (% of GDP) of Qatar?
Make the answer very short. 39.62. In the year 2004, what is the difference between the Value added (% of GDP) of Burkina Faso and Value added (% of GDP) of Qatar?
Your answer should be very brief. 16.19. In the year 2005, what is the difference between the Value added (% of GDP) of Caribbean small states and Value added (% of GDP) of Austria?
Ensure brevity in your answer.  -7.67. In the year 2005, what is the difference between the Value added (% of GDP) of Caribbean small states and Value added (% of GDP) of Burkina Faso?
Provide a succinct answer. 17.55. In the year 2005, what is the difference between the Value added (% of GDP) of Caribbean small states and Value added (% of GDP) of Qatar?
Your response must be concise. 35.17. In the year 2005, what is the difference between the Value added (% of GDP) of Austria and Value added (% of GDP) of Burkina Faso?
Give a very brief answer. 25.22. In the year 2005, what is the difference between the Value added (% of GDP) in Austria and Value added (% of GDP) in Qatar?
Your response must be concise. 42.84. In the year 2005, what is the difference between the Value added (% of GDP) in Burkina Faso and Value added (% of GDP) in Qatar?
Offer a very short reply. 17.62. In the year 2006, what is the difference between the Value added (% of GDP) in Caribbean small states and Value added (% of GDP) in Austria?
Your answer should be very brief. -8.58. In the year 2006, what is the difference between the Value added (% of GDP) of Caribbean small states and Value added (% of GDP) of Burkina Faso?
Provide a succinct answer. 13.81. In the year 2006, what is the difference between the Value added (% of GDP) in Caribbean small states and Value added (% of GDP) in Qatar?
Make the answer very short. 27.5. In the year 2006, what is the difference between the Value added (% of GDP) of Austria and Value added (% of GDP) of Burkina Faso?
Your response must be concise. 22.39. In the year 2006, what is the difference between the Value added (% of GDP) in Austria and Value added (% of GDP) in Qatar?
Ensure brevity in your answer.  36.07. In the year 2006, what is the difference between the Value added (% of GDP) of Burkina Faso and Value added (% of GDP) of Qatar?
Your response must be concise. 13.69. In the year 2007, what is the difference between the Value added (% of GDP) of Caribbean small states and Value added (% of GDP) of Austria?
Provide a succinct answer. -7.95. In the year 2007, what is the difference between the Value added (% of GDP) of Caribbean small states and Value added (% of GDP) of Burkina Faso?
Provide a succinct answer. 11.25. In the year 2007, what is the difference between the Value added (% of GDP) in Caribbean small states and Value added (% of GDP) in Qatar?
Give a very brief answer. 26.79. In the year 2007, what is the difference between the Value added (% of GDP) in Austria and Value added (% of GDP) in Burkina Faso?
Ensure brevity in your answer.  19.2. In the year 2007, what is the difference between the Value added (% of GDP) in Austria and Value added (% of GDP) in Qatar?
Ensure brevity in your answer.  34.74. In the year 2007, what is the difference between the Value added (% of GDP) of Burkina Faso and Value added (% of GDP) of Qatar?
Ensure brevity in your answer.  15.54. In the year 2008, what is the difference between the Value added (% of GDP) of Caribbean small states and Value added (% of GDP) of Austria?
Your answer should be compact. -10.22. In the year 2008, what is the difference between the Value added (% of GDP) in Caribbean small states and Value added (% of GDP) in Burkina Faso?
Your answer should be compact. 14.56. In the year 2008, what is the difference between the Value added (% of GDP) in Caribbean small states and Value added (% of GDP) in Qatar?
Your answer should be very brief. 30.81. In the year 2008, what is the difference between the Value added (% of GDP) of Austria and Value added (% of GDP) of Burkina Faso?
Provide a short and direct response. 24.78. In the year 2008, what is the difference between the Value added (% of GDP) of Austria and Value added (% of GDP) of Qatar?
Keep it short and to the point. 41.03. In the year 2008, what is the difference between the Value added (% of GDP) in Burkina Faso and Value added (% of GDP) in Qatar?
Offer a very short reply. 16.26. In the year 2009, what is the difference between the Value added (% of GDP) of Caribbean small states and Value added (% of GDP) of Austria?
Offer a very short reply. -7.07. In the year 2009, what is the difference between the Value added (% of GDP) in Caribbean small states and Value added (% of GDP) in Burkina Faso?
Keep it short and to the point. 17.62. In the year 2009, what is the difference between the Value added (% of GDP) in Caribbean small states and Value added (% of GDP) in Qatar?
Make the answer very short. 24.74. In the year 2009, what is the difference between the Value added (% of GDP) of Austria and Value added (% of GDP) of Burkina Faso?
Your answer should be compact. 24.68. In the year 2009, what is the difference between the Value added (% of GDP) of Austria and Value added (% of GDP) of Qatar?
Keep it short and to the point. 31.81. In the year 2009, what is the difference between the Value added (% of GDP) in Burkina Faso and Value added (% of GDP) in Qatar?
Offer a terse response. 7.12. What is the ratio of the Value added (% of GDP) in Caribbean small states in 2002 to that in 2003?
Provide a succinct answer. 1.04. What is the ratio of the Value added (% of GDP) of Burkina Faso in 2002 to that in 2003?
Your response must be concise. 1.05. What is the ratio of the Value added (% of GDP) of Qatar in 2002 to that in 2003?
Make the answer very short. 1.11. What is the ratio of the Value added (% of GDP) of Caribbean small states in 2002 to that in 2004?
Your answer should be very brief. 1.06. What is the ratio of the Value added (% of GDP) of Austria in 2002 to that in 2004?
Keep it short and to the point. 1. What is the ratio of the Value added (% of GDP) in Qatar in 2002 to that in 2004?
Offer a very short reply. 1.03. What is the ratio of the Value added (% of GDP) of Caribbean small states in 2002 to that in 2005?
Give a very brief answer. 1.09. What is the ratio of the Value added (% of GDP) of Austria in 2002 to that in 2005?
Give a very brief answer. 0.99. What is the ratio of the Value added (% of GDP) of Burkina Faso in 2002 to that in 2005?
Ensure brevity in your answer.  1.02. What is the ratio of the Value added (% of GDP) in Qatar in 2002 to that in 2005?
Provide a short and direct response. 1.15. What is the ratio of the Value added (% of GDP) of Caribbean small states in 2002 to that in 2006?
Give a very brief answer. 1.11. What is the ratio of the Value added (% of GDP) in Austria in 2002 to that in 2006?
Your answer should be compact. 0.99. What is the ratio of the Value added (% of GDP) of Burkina Faso in 2002 to that in 2006?
Give a very brief answer. 0.96. What is the ratio of the Value added (% of GDP) in Qatar in 2002 to that in 2006?
Provide a succinct answer. 0.91. What is the ratio of the Value added (% of GDP) of Caribbean small states in 2002 to that in 2007?
Offer a very short reply. 1.1. What is the ratio of the Value added (% of GDP) of Burkina Faso in 2002 to that in 2007?
Ensure brevity in your answer.  0.91. What is the ratio of the Value added (% of GDP) in Qatar in 2002 to that in 2007?
Give a very brief answer. 0.89. What is the ratio of the Value added (% of GDP) of Caribbean small states in 2002 to that in 2008?
Offer a very short reply. 1.13. What is the ratio of the Value added (% of GDP) in Austria in 2002 to that in 2008?
Your answer should be very brief. 0.99. What is the ratio of the Value added (% of GDP) of Burkina Faso in 2002 to that in 2008?
Make the answer very short. 1.01. What is the ratio of the Value added (% of GDP) in Qatar in 2002 to that in 2008?
Provide a succinct answer. 1.06. What is the ratio of the Value added (% of GDP) of Caribbean small states in 2002 to that in 2009?
Give a very brief answer. 1.05. What is the ratio of the Value added (% of GDP) of Austria in 2002 to that in 2009?
Offer a terse response. 0.97. What is the ratio of the Value added (% of GDP) of Burkina Faso in 2002 to that in 2009?
Your response must be concise. 0.97. What is the ratio of the Value added (% of GDP) in Qatar in 2002 to that in 2009?
Your answer should be very brief. 0.77. What is the ratio of the Value added (% of GDP) in Caribbean small states in 2003 to that in 2004?
Make the answer very short. 1.01. What is the ratio of the Value added (% of GDP) in Austria in 2003 to that in 2004?
Keep it short and to the point. 1. What is the ratio of the Value added (% of GDP) in Burkina Faso in 2003 to that in 2004?
Give a very brief answer. 0.94. What is the ratio of the Value added (% of GDP) in Qatar in 2003 to that in 2004?
Offer a very short reply. 0.93. What is the ratio of the Value added (% of GDP) of Caribbean small states in 2003 to that in 2005?
Your response must be concise. 1.04. What is the ratio of the Value added (% of GDP) of Austria in 2003 to that in 2005?
Your answer should be very brief. 0.99. What is the ratio of the Value added (% of GDP) in Burkina Faso in 2003 to that in 2005?
Your response must be concise. 0.97. What is the ratio of the Value added (% of GDP) in Qatar in 2003 to that in 2005?
Provide a succinct answer. 1.04. What is the ratio of the Value added (% of GDP) of Caribbean small states in 2003 to that in 2006?
Offer a terse response. 1.06. What is the ratio of the Value added (% of GDP) in Burkina Faso in 2003 to that in 2006?
Give a very brief answer. 0.91. What is the ratio of the Value added (% of GDP) in Qatar in 2003 to that in 2006?
Your answer should be compact. 0.82. What is the ratio of the Value added (% of GDP) in Caribbean small states in 2003 to that in 2007?
Your response must be concise. 1.06. What is the ratio of the Value added (% of GDP) in Austria in 2003 to that in 2007?
Your answer should be very brief. 1. What is the ratio of the Value added (% of GDP) in Burkina Faso in 2003 to that in 2007?
Provide a succinct answer. 0.86. What is the ratio of the Value added (% of GDP) in Qatar in 2003 to that in 2007?
Make the answer very short. 0.8. What is the ratio of the Value added (% of GDP) in Caribbean small states in 2003 to that in 2008?
Offer a very short reply. 1.09. What is the ratio of the Value added (% of GDP) of Burkina Faso in 2003 to that in 2008?
Give a very brief answer. 0.96. What is the ratio of the Value added (% of GDP) of Qatar in 2003 to that in 2008?
Offer a terse response. 0.96. What is the ratio of the Value added (% of GDP) in Caribbean small states in 2003 to that in 2009?
Your answer should be compact. 1.01. What is the ratio of the Value added (% of GDP) of Austria in 2003 to that in 2009?
Your answer should be compact. 0.97. What is the ratio of the Value added (% of GDP) of Burkina Faso in 2003 to that in 2009?
Make the answer very short. 0.93. What is the ratio of the Value added (% of GDP) of Qatar in 2003 to that in 2009?
Your answer should be compact. 0.69. What is the ratio of the Value added (% of GDP) of Caribbean small states in 2004 to that in 2005?
Make the answer very short. 1.03. What is the ratio of the Value added (% of GDP) of Burkina Faso in 2004 to that in 2005?
Ensure brevity in your answer.  1.03. What is the ratio of the Value added (% of GDP) of Qatar in 2004 to that in 2005?
Offer a terse response. 1.11. What is the ratio of the Value added (% of GDP) of Caribbean small states in 2004 to that in 2006?
Ensure brevity in your answer.  1.05. What is the ratio of the Value added (% of GDP) of Burkina Faso in 2004 to that in 2006?
Keep it short and to the point. 0.97. What is the ratio of the Value added (% of GDP) in Qatar in 2004 to that in 2006?
Provide a short and direct response. 0.88. What is the ratio of the Value added (% of GDP) in Caribbean small states in 2004 to that in 2007?
Offer a terse response. 1.05. What is the ratio of the Value added (% of GDP) of Burkina Faso in 2004 to that in 2007?
Offer a very short reply. 0.92. What is the ratio of the Value added (% of GDP) of Qatar in 2004 to that in 2007?
Your answer should be very brief. 0.86. What is the ratio of the Value added (% of GDP) in Caribbean small states in 2004 to that in 2008?
Your answer should be very brief. 1.07. What is the ratio of the Value added (% of GDP) in Austria in 2004 to that in 2008?
Your answer should be very brief. 0.99. What is the ratio of the Value added (% of GDP) of Burkina Faso in 2004 to that in 2008?
Your answer should be very brief. 1.02. What is the ratio of the Value added (% of GDP) of Qatar in 2004 to that in 2008?
Provide a short and direct response. 1.03. What is the ratio of the Value added (% of GDP) in Austria in 2004 to that in 2009?
Ensure brevity in your answer.  0.97. What is the ratio of the Value added (% of GDP) in Burkina Faso in 2004 to that in 2009?
Your answer should be very brief. 0.98. What is the ratio of the Value added (% of GDP) of Qatar in 2004 to that in 2009?
Provide a succinct answer. 0.74. What is the ratio of the Value added (% of GDP) of Caribbean small states in 2005 to that in 2006?
Ensure brevity in your answer.  1.02. What is the ratio of the Value added (% of GDP) in Burkina Faso in 2005 to that in 2006?
Your answer should be compact. 0.94. What is the ratio of the Value added (% of GDP) of Qatar in 2005 to that in 2006?
Offer a terse response. 0.79. What is the ratio of the Value added (% of GDP) of Caribbean small states in 2005 to that in 2007?
Offer a very short reply. 1.02. What is the ratio of the Value added (% of GDP) of Austria in 2005 to that in 2007?
Provide a short and direct response. 1.01. What is the ratio of the Value added (% of GDP) of Burkina Faso in 2005 to that in 2007?
Your response must be concise. 0.89. What is the ratio of the Value added (% of GDP) in Qatar in 2005 to that in 2007?
Ensure brevity in your answer.  0.77. What is the ratio of the Value added (% of GDP) in Caribbean small states in 2005 to that in 2008?
Provide a short and direct response. 1.04. What is the ratio of the Value added (% of GDP) of Burkina Faso in 2005 to that in 2008?
Give a very brief answer. 0.99. What is the ratio of the Value added (% of GDP) of Qatar in 2005 to that in 2008?
Give a very brief answer. 0.93. What is the ratio of the Value added (% of GDP) of Caribbean small states in 2005 to that in 2009?
Provide a succinct answer. 0.97. What is the ratio of the Value added (% of GDP) of Austria in 2005 to that in 2009?
Provide a succinct answer. 0.98. What is the ratio of the Value added (% of GDP) of Burkina Faso in 2005 to that in 2009?
Make the answer very short. 0.95. What is the ratio of the Value added (% of GDP) of Qatar in 2005 to that in 2009?
Provide a short and direct response. 0.67. What is the ratio of the Value added (% of GDP) in Caribbean small states in 2006 to that in 2007?
Provide a short and direct response. 1. What is the ratio of the Value added (% of GDP) of Austria in 2006 to that in 2007?
Keep it short and to the point. 1.01. What is the ratio of the Value added (% of GDP) in Burkina Faso in 2006 to that in 2007?
Your answer should be very brief. 0.94. What is the ratio of the Value added (% of GDP) in Qatar in 2006 to that in 2007?
Make the answer very short. 0.97. What is the ratio of the Value added (% of GDP) in Caribbean small states in 2006 to that in 2008?
Your answer should be compact. 1.02. What is the ratio of the Value added (% of GDP) in Burkina Faso in 2006 to that in 2008?
Provide a short and direct response. 1.05. What is the ratio of the Value added (% of GDP) in Qatar in 2006 to that in 2008?
Make the answer very short. 1.17. What is the ratio of the Value added (% of GDP) of Caribbean small states in 2006 to that in 2009?
Your response must be concise. 0.95. What is the ratio of the Value added (% of GDP) in Austria in 2006 to that in 2009?
Offer a terse response. 0.97. What is the ratio of the Value added (% of GDP) of Burkina Faso in 2006 to that in 2009?
Offer a very short reply. 1.01. What is the ratio of the Value added (% of GDP) of Qatar in 2006 to that in 2009?
Make the answer very short. 0.84. What is the ratio of the Value added (% of GDP) in Caribbean small states in 2007 to that in 2008?
Offer a very short reply. 1.03. What is the ratio of the Value added (% of GDP) of Burkina Faso in 2007 to that in 2008?
Offer a very short reply. 1.11. What is the ratio of the Value added (% of GDP) of Qatar in 2007 to that in 2008?
Your response must be concise. 1.2. What is the ratio of the Value added (% of GDP) of Caribbean small states in 2007 to that in 2009?
Your response must be concise. 0.95. What is the ratio of the Value added (% of GDP) in Austria in 2007 to that in 2009?
Make the answer very short. 0.97. What is the ratio of the Value added (% of GDP) of Burkina Faso in 2007 to that in 2009?
Offer a terse response. 1.07. What is the ratio of the Value added (% of GDP) in Qatar in 2007 to that in 2009?
Make the answer very short. 0.86. What is the ratio of the Value added (% of GDP) of Caribbean small states in 2008 to that in 2009?
Give a very brief answer. 0.93. What is the ratio of the Value added (% of GDP) in Austria in 2008 to that in 2009?
Offer a terse response. 0.98. What is the ratio of the Value added (% of GDP) in Burkina Faso in 2008 to that in 2009?
Offer a very short reply. 0.97. What is the ratio of the Value added (% of GDP) of Qatar in 2008 to that in 2009?
Make the answer very short. 0.72. What is the difference between the highest and the second highest Value added (% of GDP) in Caribbean small states?
Provide a succinct answer. 2.69. What is the difference between the highest and the second highest Value added (% of GDP) in Austria?
Ensure brevity in your answer.  1.43. What is the difference between the highest and the second highest Value added (% of GDP) of Burkina Faso?
Provide a succinct answer. 2.72. What is the difference between the highest and the second highest Value added (% of GDP) in Qatar?
Provide a short and direct response. 5.14. What is the difference between the highest and the lowest Value added (% of GDP) in Caribbean small states?
Provide a succinct answer. 7.75. What is the difference between the highest and the lowest Value added (% of GDP) of Austria?
Provide a short and direct response. 2.21. What is the difference between the highest and the lowest Value added (% of GDP) of Burkina Faso?
Your response must be concise. 6.63. What is the difference between the highest and the lowest Value added (% of GDP) in Qatar?
Give a very brief answer. 12.61. 